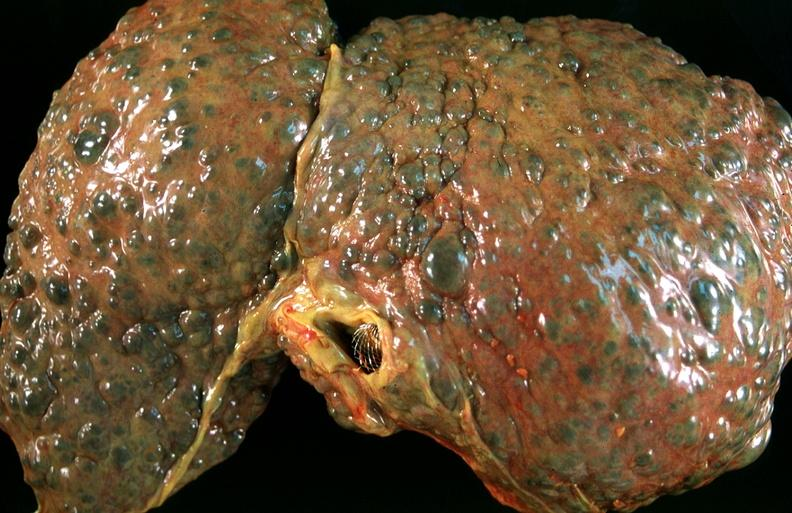does this image show liver, macronodular cirrhosis, hcv?
Answer the question using a single word or phrase. Yes 